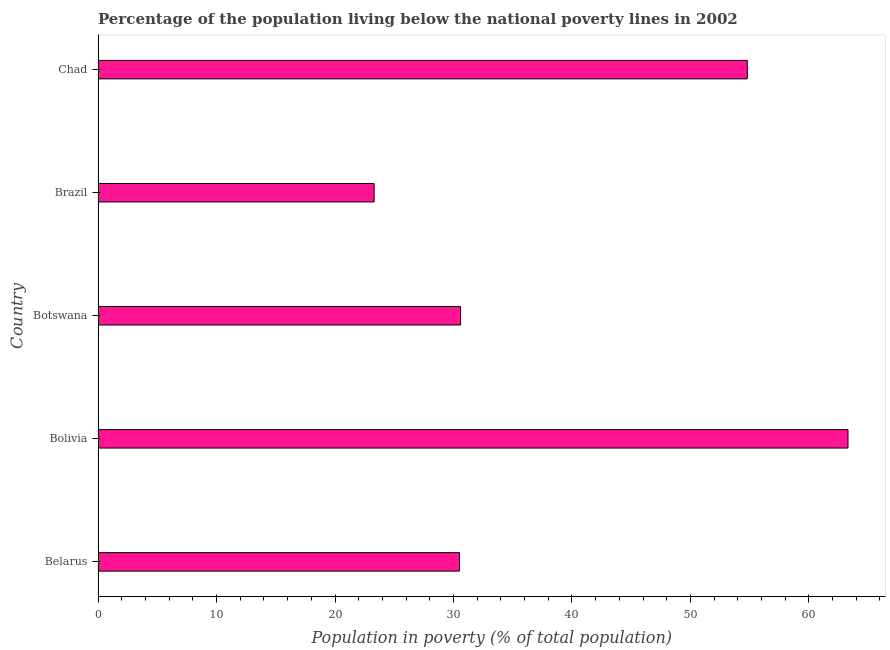Does the graph contain grids?
Provide a short and direct response. No. What is the title of the graph?
Keep it short and to the point. Percentage of the population living below the national poverty lines in 2002. What is the label or title of the X-axis?
Your answer should be very brief. Population in poverty (% of total population). What is the label or title of the Y-axis?
Provide a short and direct response. Country. What is the percentage of population living below poverty line in Chad?
Provide a short and direct response. 54.8. Across all countries, what is the maximum percentage of population living below poverty line?
Offer a very short reply. 63.3. Across all countries, what is the minimum percentage of population living below poverty line?
Offer a terse response. 23.3. In which country was the percentage of population living below poverty line maximum?
Keep it short and to the point. Bolivia. What is the sum of the percentage of population living below poverty line?
Your response must be concise. 202.5. What is the difference between the percentage of population living below poverty line in Brazil and Chad?
Offer a terse response. -31.5. What is the average percentage of population living below poverty line per country?
Provide a succinct answer. 40.5. What is the median percentage of population living below poverty line?
Make the answer very short. 30.6. What is the ratio of the percentage of population living below poverty line in Bolivia to that in Brazil?
Provide a succinct answer. 2.72. Is the difference between the percentage of population living below poverty line in Belarus and Bolivia greater than the difference between any two countries?
Give a very brief answer. No. What is the difference between the highest and the second highest percentage of population living below poverty line?
Your response must be concise. 8.5. Is the sum of the percentage of population living below poverty line in Bolivia and Botswana greater than the maximum percentage of population living below poverty line across all countries?
Your response must be concise. Yes. What is the difference between the highest and the lowest percentage of population living below poverty line?
Make the answer very short. 40. In how many countries, is the percentage of population living below poverty line greater than the average percentage of population living below poverty line taken over all countries?
Offer a terse response. 2. How many countries are there in the graph?
Ensure brevity in your answer.  5. What is the difference between two consecutive major ticks on the X-axis?
Your answer should be compact. 10. Are the values on the major ticks of X-axis written in scientific E-notation?
Offer a terse response. No. What is the Population in poverty (% of total population) of Belarus?
Offer a very short reply. 30.5. What is the Population in poverty (% of total population) in Bolivia?
Give a very brief answer. 63.3. What is the Population in poverty (% of total population) in Botswana?
Provide a succinct answer. 30.6. What is the Population in poverty (% of total population) in Brazil?
Offer a terse response. 23.3. What is the Population in poverty (% of total population) in Chad?
Your response must be concise. 54.8. What is the difference between the Population in poverty (% of total population) in Belarus and Bolivia?
Your answer should be very brief. -32.8. What is the difference between the Population in poverty (% of total population) in Belarus and Chad?
Offer a very short reply. -24.3. What is the difference between the Population in poverty (% of total population) in Bolivia and Botswana?
Your answer should be compact. 32.7. What is the difference between the Population in poverty (% of total population) in Botswana and Chad?
Provide a short and direct response. -24.2. What is the difference between the Population in poverty (% of total population) in Brazil and Chad?
Provide a short and direct response. -31.5. What is the ratio of the Population in poverty (% of total population) in Belarus to that in Bolivia?
Keep it short and to the point. 0.48. What is the ratio of the Population in poverty (% of total population) in Belarus to that in Brazil?
Offer a terse response. 1.31. What is the ratio of the Population in poverty (% of total population) in Belarus to that in Chad?
Offer a very short reply. 0.56. What is the ratio of the Population in poverty (% of total population) in Bolivia to that in Botswana?
Offer a very short reply. 2.07. What is the ratio of the Population in poverty (% of total population) in Bolivia to that in Brazil?
Your response must be concise. 2.72. What is the ratio of the Population in poverty (% of total population) in Bolivia to that in Chad?
Your answer should be very brief. 1.16. What is the ratio of the Population in poverty (% of total population) in Botswana to that in Brazil?
Provide a short and direct response. 1.31. What is the ratio of the Population in poverty (% of total population) in Botswana to that in Chad?
Offer a terse response. 0.56. What is the ratio of the Population in poverty (% of total population) in Brazil to that in Chad?
Your answer should be very brief. 0.42. 